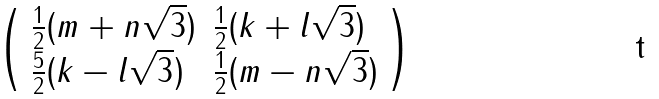Convert formula to latex. <formula><loc_0><loc_0><loc_500><loc_500>\left ( \begin{array} { l l } \frac { 1 } { 2 } ( m + n \sqrt { 3 } ) & \frac { 1 } { 2 } ( k + l \sqrt { 3 } ) \\ \frac { 5 } { 2 } ( k - l \sqrt { 3 } ) & \frac { 1 } { 2 } ( m - n \sqrt { 3 } ) \end{array} \right )</formula> 